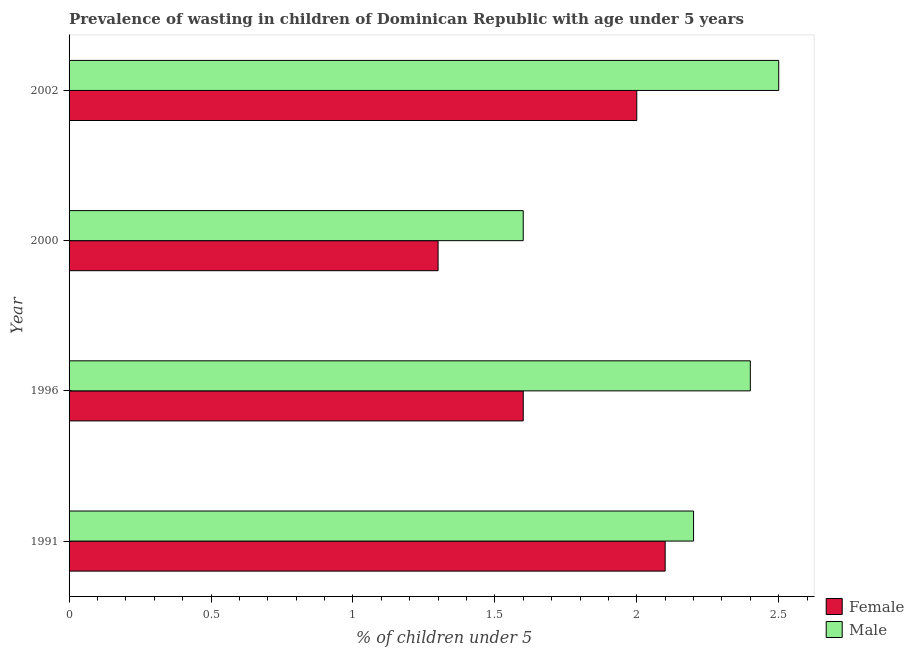Are the number of bars on each tick of the Y-axis equal?
Your answer should be compact. Yes. How many bars are there on the 2nd tick from the top?
Keep it short and to the point. 2. How many bars are there on the 1st tick from the bottom?
Provide a succinct answer. 2. Across all years, what is the maximum percentage of undernourished female children?
Your answer should be compact. 2.1. Across all years, what is the minimum percentage of undernourished female children?
Offer a very short reply. 1.3. In which year was the percentage of undernourished female children maximum?
Your response must be concise. 1991. In which year was the percentage of undernourished male children minimum?
Keep it short and to the point. 2000. What is the total percentage of undernourished male children in the graph?
Ensure brevity in your answer.  8.7. What is the difference between the percentage of undernourished female children in 2002 and the percentage of undernourished male children in 1991?
Ensure brevity in your answer.  -0.2. What is the average percentage of undernourished male children per year?
Offer a terse response. 2.17. In the year 1996, what is the difference between the percentage of undernourished female children and percentage of undernourished male children?
Ensure brevity in your answer.  -0.8. What is the ratio of the percentage of undernourished female children in 1996 to that in 2000?
Keep it short and to the point. 1.23. Is the percentage of undernourished female children in 1996 less than that in 2002?
Provide a short and direct response. Yes. Is the difference between the percentage of undernourished male children in 1991 and 2002 greater than the difference between the percentage of undernourished female children in 1991 and 2002?
Your answer should be very brief. No. What is the difference between the highest and the second highest percentage of undernourished male children?
Your answer should be compact. 0.1. What is the difference between the highest and the lowest percentage of undernourished female children?
Provide a short and direct response. 0.8. In how many years, is the percentage of undernourished male children greater than the average percentage of undernourished male children taken over all years?
Your response must be concise. 3. Is the sum of the percentage of undernourished male children in 2000 and 2002 greater than the maximum percentage of undernourished female children across all years?
Offer a very short reply. Yes. What does the 2nd bar from the bottom in 2000 represents?
Offer a very short reply. Male. How many bars are there?
Offer a terse response. 8. What is the difference between two consecutive major ticks on the X-axis?
Your response must be concise. 0.5. Does the graph contain grids?
Provide a succinct answer. No. How many legend labels are there?
Offer a very short reply. 2. How are the legend labels stacked?
Make the answer very short. Vertical. What is the title of the graph?
Provide a short and direct response. Prevalence of wasting in children of Dominican Republic with age under 5 years. Does "Malaria" appear as one of the legend labels in the graph?
Your response must be concise. No. What is the label or title of the X-axis?
Ensure brevity in your answer.   % of children under 5. What is the  % of children under 5 of Female in 1991?
Your response must be concise. 2.1. What is the  % of children under 5 of Male in 1991?
Make the answer very short. 2.2. What is the  % of children under 5 in Female in 1996?
Offer a very short reply. 1.6. What is the  % of children under 5 of Male in 1996?
Offer a terse response. 2.4. What is the  % of children under 5 of Female in 2000?
Offer a terse response. 1.3. What is the  % of children under 5 of Male in 2000?
Offer a very short reply. 1.6. What is the  % of children under 5 of Female in 2002?
Give a very brief answer. 2. What is the  % of children under 5 in Male in 2002?
Your answer should be very brief. 2.5. Across all years, what is the maximum  % of children under 5 in Female?
Provide a succinct answer. 2.1. Across all years, what is the maximum  % of children under 5 in Male?
Your answer should be very brief. 2.5. Across all years, what is the minimum  % of children under 5 of Female?
Offer a terse response. 1.3. Across all years, what is the minimum  % of children under 5 in Male?
Your answer should be compact. 1.6. What is the total  % of children under 5 in Female in the graph?
Offer a terse response. 7. What is the total  % of children under 5 in Male in the graph?
Make the answer very short. 8.7. What is the difference between the  % of children under 5 in Female in 1991 and that in 1996?
Provide a short and direct response. 0.5. What is the difference between the  % of children under 5 in Female in 1991 and that in 2000?
Provide a succinct answer. 0.8. What is the difference between the  % of children under 5 of Male in 1991 and that in 2000?
Your answer should be compact. 0.6. What is the difference between the  % of children under 5 of Male in 1996 and that in 2000?
Ensure brevity in your answer.  0.8. What is the difference between the  % of children under 5 in Male in 2000 and that in 2002?
Provide a succinct answer. -0.9. What is the difference between the  % of children under 5 in Female in 1991 and the  % of children under 5 in Male in 1996?
Make the answer very short. -0.3. What is the difference between the  % of children under 5 of Female in 1991 and the  % of children under 5 of Male in 2000?
Ensure brevity in your answer.  0.5. What is the difference between the  % of children under 5 in Female in 1991 and the  % of children under 5 in Male in 2002?
Your answer should be very brief. -0.4. What is the difference between the  % of children under 5 of Female in 1996 and the  % of children under 5 of Male in 2000?
Ensure brevity in your answer.  0. What is the difference between the  % of children under 5 in Female in 1996 and the  % of children under 5 in Male in 2002?
Your answer should be compact. -0.9. What is the average  % of children under 5 in Female per year?
Your answer should be compact. 1.75. What is the average  % of children under 5 of Male per year?
Provide a short and direct response. 2.17. In the year 1991, what is the difference between the  % of children under 5 of Female and  % of children under 5 of Male?
Offer a very short reply. -0.1. What is the ratio of the  % of children under 5 of Female in 1991 to that in 1996?
Provide a short and direct response. 1.31. What is the ratio of the  % of children under 5 of Male in 1991 to that in 1996?
Make the answer very short. 0.92. What is the ratio of the  % of children under 5 in Female in 1991 to that in 2000?
Your response must be concise. 1.62. What is the ratio of the  % of children under 5 in Male in 1991 to that in 2000?
Your answer should be compact. 1.38. What is the ratio of the  % of children under 5 of Female in 1996 to that in 2000?
Provide a short and direct response. 1.23. What is the ratio of the  % of children under 5 of Male in 1996 to that in 2000?
Offer a very short reply. 1.5. What is the ratio of the  % of children under 5 of Female in 1996 to that in 2002?
Provide a short and direct response. 0.8. What is the ratio of the  % of children under 5 in Male in 1996 to that in 2002?
Keep it short and to the point. 0.96. What is the ratio of the  % of children under 5 in Female in 2000 to that in 2002?
Provide a short and direct response. 0.65. What is the ratio of the  % of children under 5 in Male in 2000 to that in 2002?
Provide a short and direct response. 0.64. What is the difference between the highest and the second highest  % of children under 5 of Female?
Your answer should be compact. 0.1. What is the difference between the highest and the lowest  % of children under 5 in Female?
Provide a succinct answer. 0.8. 